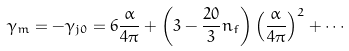<formula> <loc_0><loc_0><loc_500><loc_500>\gamma _ { m } = - \gamma _ { j 0 } = 6 \frac { \alpha } { 4 \pi } + \left ( 3 - \frac { 2 0 } { 3 } n _ { f } \right ) \left ( \frac { \alpha } { 4 \pi } \right ) ^ { 2 } + \cdots</formula> 